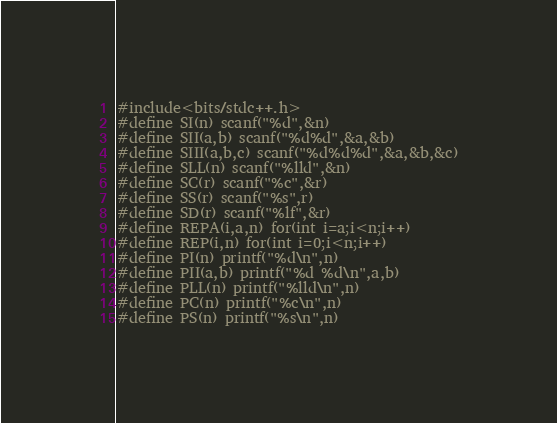<code> <loc_0><loc_0><loc_500><loc_500><_C++_>#include<bits/stdc++.h>
#define SI(n) scanf("%d",&n)
#define SII(a,b) scanf("%d%d",&a,&b)
#define SIII(a,b,c) scanf("%d%d%d",&a,&b,&c)
#define SLL(n) scanf("%lld",&n)
#define SC(r) scanf("%c",&r)
#define SS(r) scanf("%s",r)
#define SD(r) scanf("%lf",&r)
#define REPA(i,a,n) for(int i=a;i<n;i++)
#define REP(i,n) for(int i=0;i<n;i++)
#define PI(n) printf("%d\n",n)
#define PII(a,b) printf("%d %d\n",a,b)
#define PLL(n) printf("%lld\n",n)
#define PC(n) printf("%c\n",n)
#define PS(n) printf("%s\n",n)</code> 